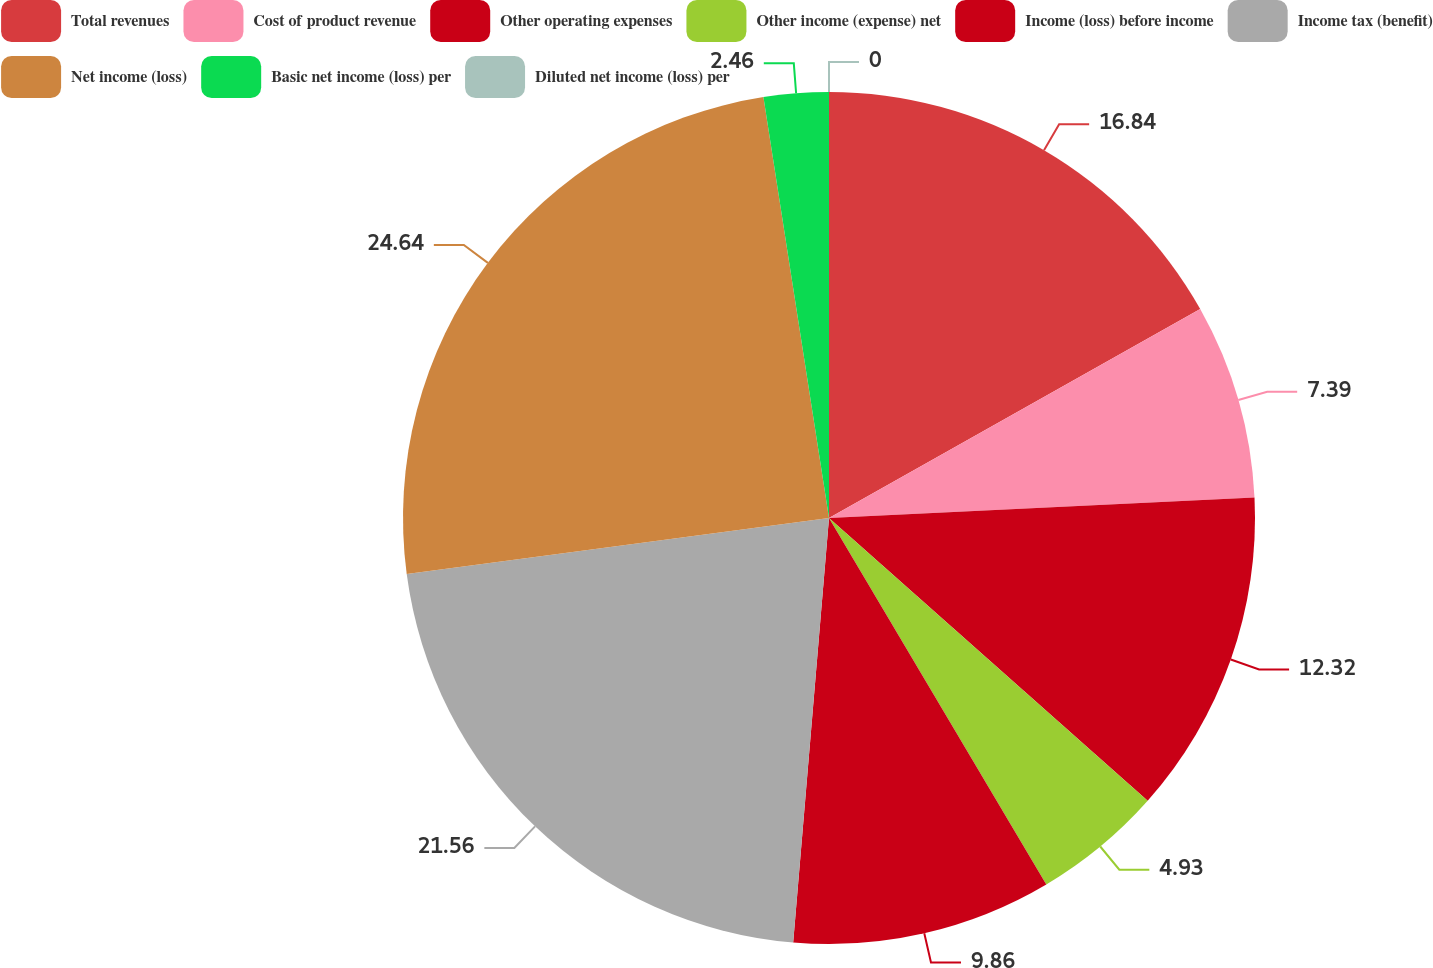Convert chart. <chart><loc_0><loc_0><loc_500><loc_500><pie_chart><fcel>Total revenues<fcel>Cost of product revenue<fcel>Other operating expenses<fcel>Other income (expense) net<fcel>Income (loss) before income<fcel>Income tax (benefit)<fcel>Net income (loss)<fcel>Basic net income (loss) per<fcel>Diluted net income (loss) per<nl><fcel>16.84%<fcel>7.39%<fcel>12.32%<fcel>4.93%<fcel>9.86%<fcel>21.56%<fcel>24.64%<fcel>2.46%<fcel>0.0%<nl></chart> 